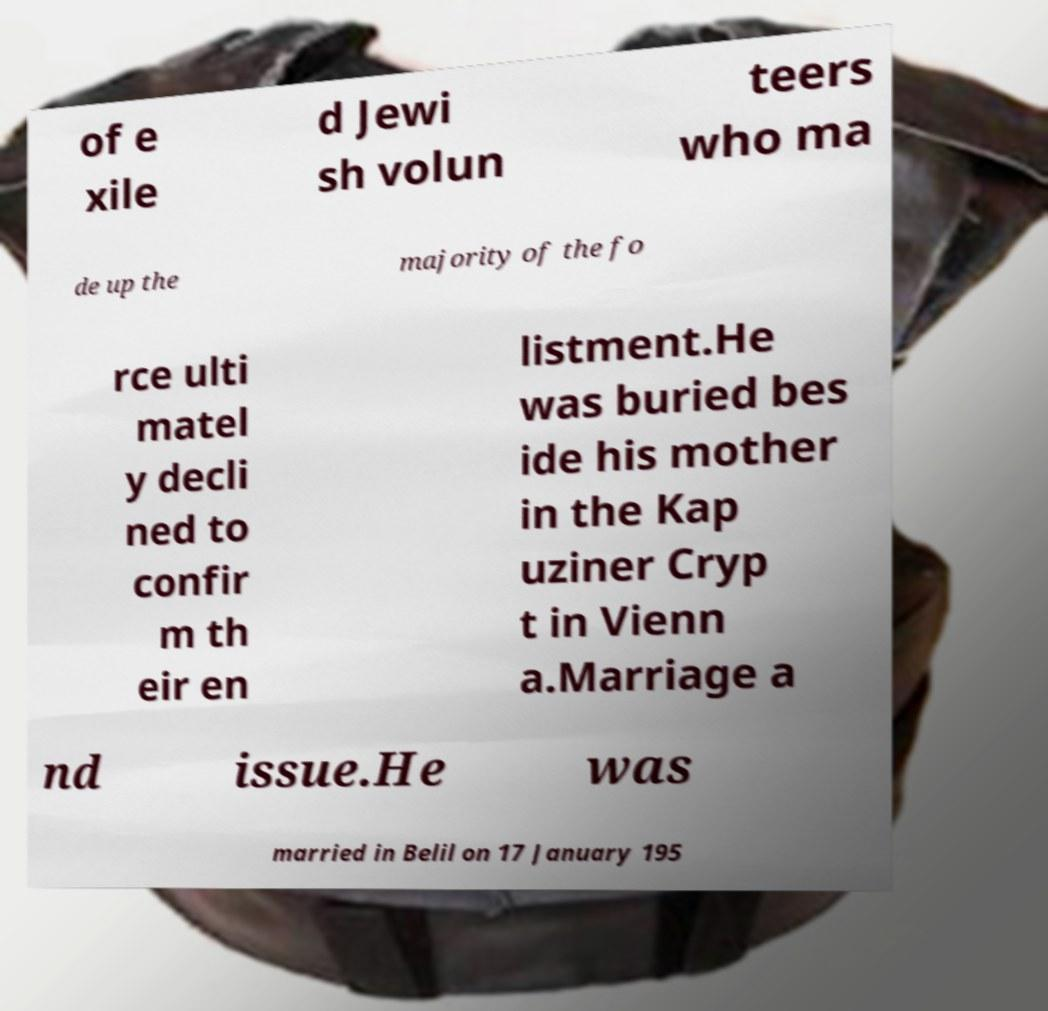Can you read and provide the text displayed in the image?This photo seems to have some interesting text. Can you extract and type it out for me? of e xile d Jewi sh volun teers who ma de up the majority of the fo rce ulti matel y decli ned to confir m th eir en listment.He was buried bes ide his mother in the Kap uziner Cryp t in Vienn a.Marriage a nd issue.He was married in Belil on 17 January 195 